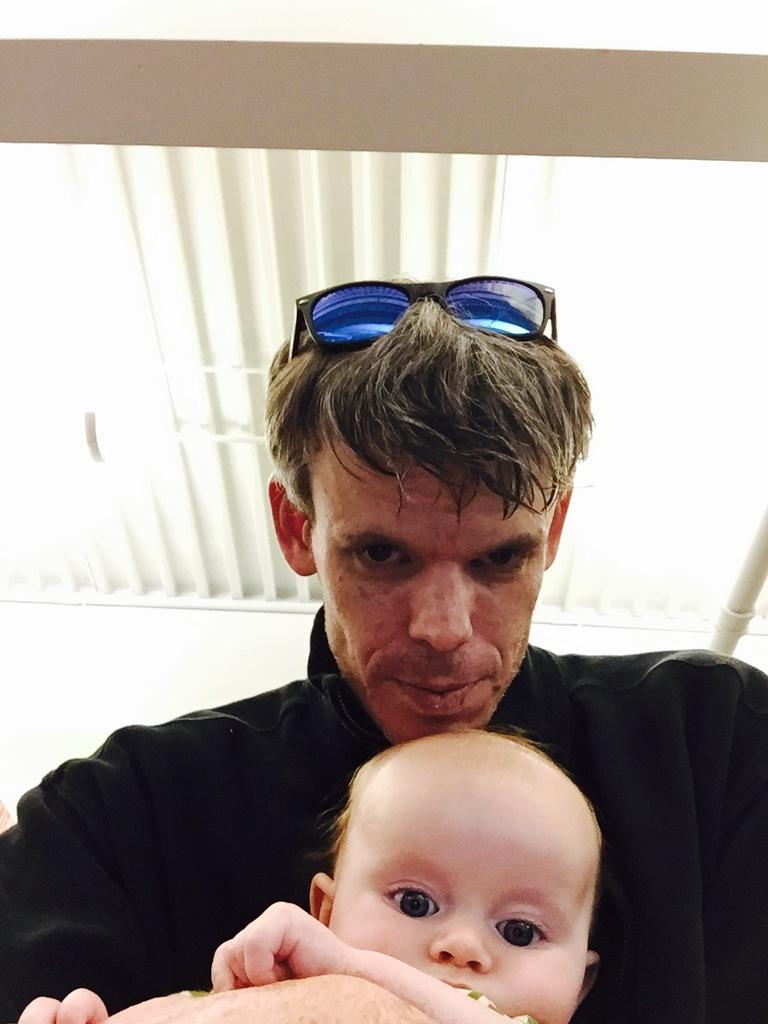Who is present in the image? There is a man and a kid in the image. What can be seen at the top of the image? The ceiling is visible at the top of the image. Where is the faucet located in the image? There is no faucet present in the image. What type of store can be seen in the background of the image? There is no store visible in the image; it only features a man, a kid, and a ceiling. 